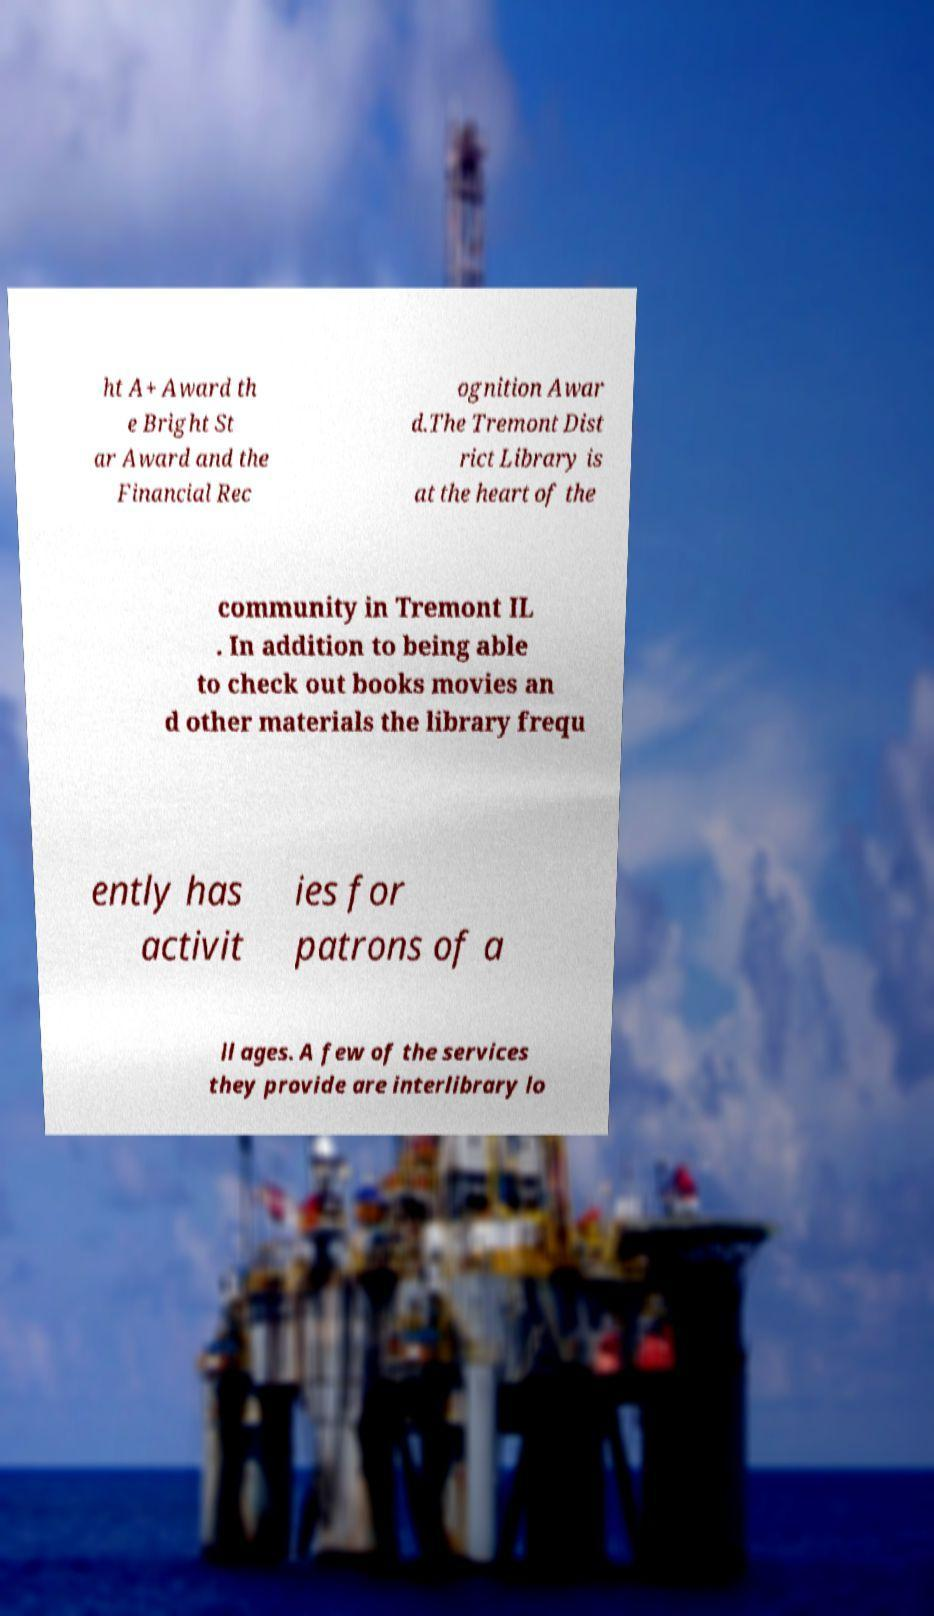What messages or text are displayed in this image? I need them in a readable, typed format. ht A+ Award th e Bright St ar Award and the Financial Rec ognition Awar d.The Tremont Dist rict Library is at the heart of the community in Tremont IL . In addition to being able to check out books movies an d other materials the library frequ ently has activit ies for patrons of a ll ages. A few of the services they provide are interlibrary lo 